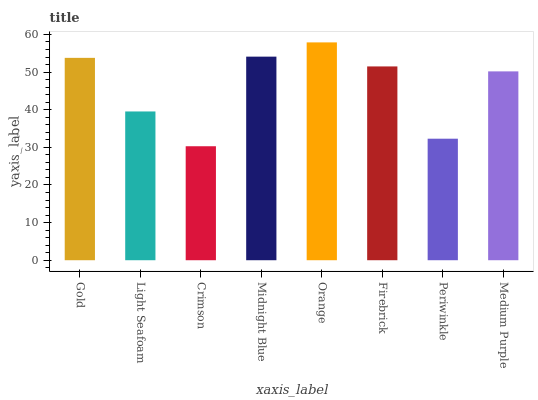Is Crimson the minimum?
Answer yes or no. Yes. Is Orange the maximum?
Answer yes or no. Yes. Is Light Seafoam the minimum?
Answer yes or no. No. Is Light Seafoam the maximum?
Answer yes or no. No. Is Gold greater than Light Seafoam?
Answer yes or no. Yes. Is Light Seafoam less than Gold?
Answer yes or no. Yes. Is Light Seafoam greater than Gold?
Answer yes or no. No. Is Gold less than Light Seafoam?
Answer yes or no. No. Is Firebrick the high median?
Answer yes or no. Yes. Is Medium Purple the low median?
Answer yes or no. Yes. Is Gold the high median?
Answer yes or no. No. Is Firebrick the low median?
Answer yes or no. No. 